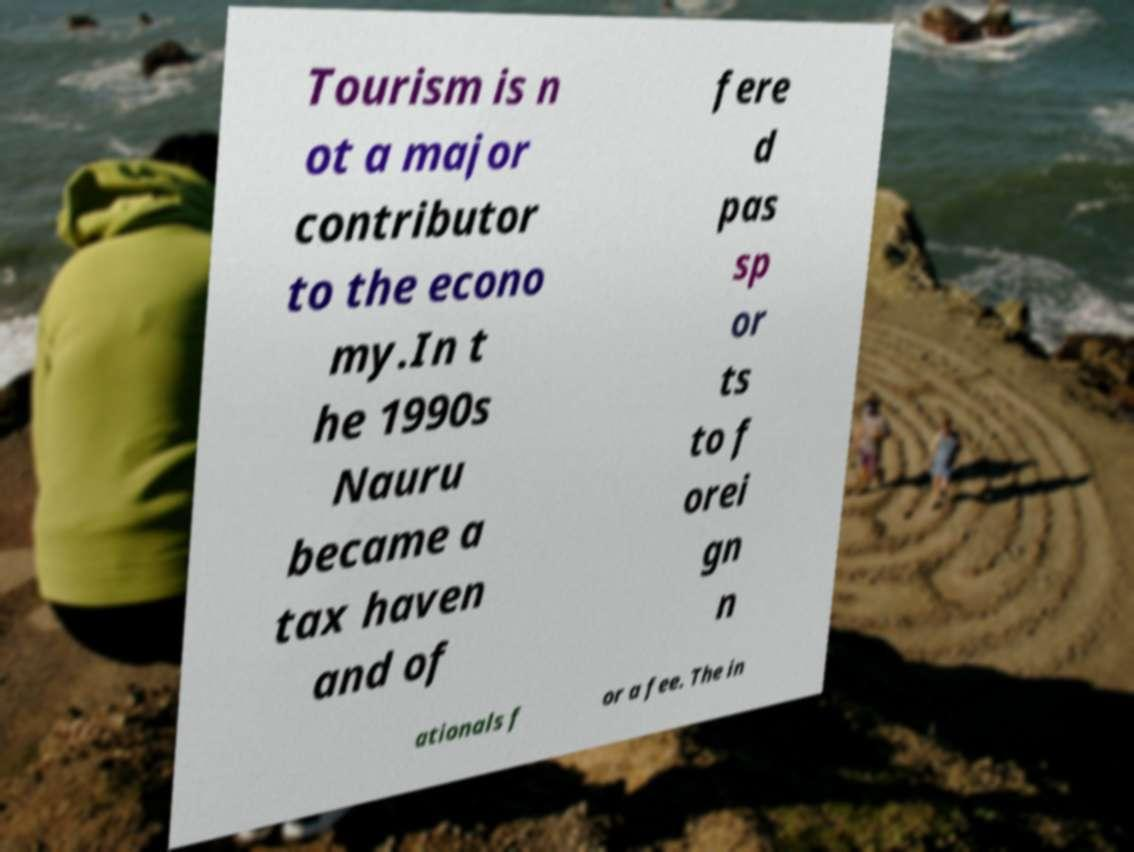Can you accurately transcribe the text from the provided image for me? Tourism is n ot a major contributor to the econo my.In t he 1990s Nauru became a tax haven and of fere d pas sp or ts to f orei gn n ationals f or a fee. The in 